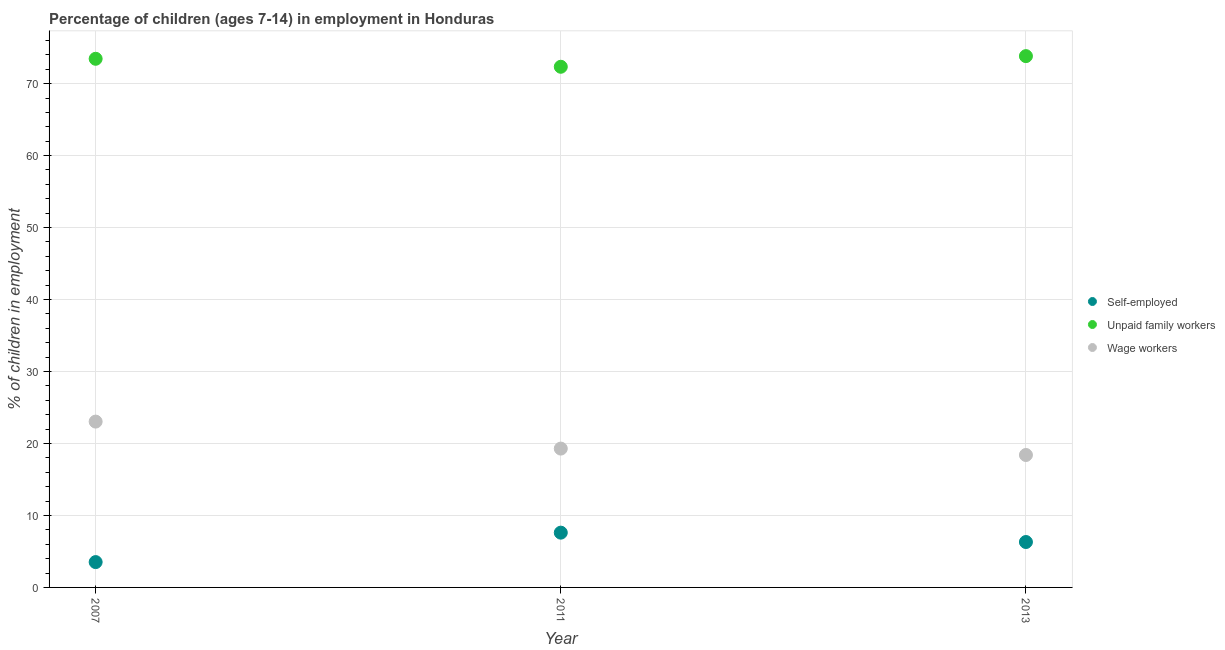How many different coloured dotlines are there?
Offer a terse response. 3. What is the percentage of self employed children in 2011?
Offer a terse response. 7.61. Across all years, what is the maximum percentage of self employed children?
Ensure brevity in your answer.  7.61. Across all years, what is the minimum percentage of children employed as unpaid family workers?
Offer a terse response. 72.34. In which year was the percentage of children employed as unpaid family workers maximum?
Offer a very short reply. 2013. What is the total percentage of self employed children in the graph?
Your answer should be very brief. 17.44. What is the difference between the percentage of children employed as wage workers in 2007 and that in 2011?
Provide a short and direct response. 3.75. What is the difference between the percentage of self employed children in 2011 and the percentage of children employed as unpaid family workers in 2013?
Your answer should be compact. -66.21. What is the average percentage of children employed as unpaid family workers per year?
Give a very brief answer. 73.2. In the year 2011, what is the difference between the percentage of children employed as unpaid family workers and percentage of self employed children?
Provide a succinct answer. 64.73. In how many years, is the percentage of children employed as wage workers greater than 16 %?
Ensure brevity in your answer.  3. What is the ratio of the percentage of children employed as wage workers in 2007 to that in 2013?
Your answer should be very brief. 1.25. Is the percentage of children employed as wage workers in 2007 less than that in 2011?
Keep it short and to the point. No. Is the difference between the percentage of children employed as unpaid family workers in 2007 and 2013 greater than the difference between the percentage of self employed children in 2007 and 2013?
Your response must be concise. Yes. What is the difference between the highest and the second highest percentage of children employed as wage workers?
Provide a succinct answer. 3.75. What is the difference between the highest and the lowest percentage of children employed as unpaid family workers?
Provide a succinct answer. 1.48. Does the percentage of children employed as unpaid family workers monotonically increase over the years?
Make the answer very short. No. Is the percentage of children employed as wage workers strictly greater than the percentage of self employed children over the years?
Your response must be concise. Yes. Is the percentage of children employed as wage workers strictly less than the percentage of children employed as unpaid family workers over the years?
Offer a terse response. Yes. How many dotlines are there?
Make the answer very short. 3. How many years are there in the graph?
Keep it short and to the point. 3. Are the values on the major ticks of Y-axis written in scientific E-notation?
Provide a succinct answer. No. How many legend labels are there?
Your answer should be compact. 3. How are the legend labels stacked?
Ensure brevity in your answer.  Vertical. What is the title of the graph?
Keep it short and to the point. Percentage of children (ages 7-14) in employment in Honduras. Does "Spain" appear as one of the legend labels in the graph?
Provide a short and direct response. No. What is the label or title of the Y-axis?
Offer a very short reply. % of children in employment. What is the % of children in employment of Self-employed in 2007?
Keep it short and to the point. 3.52. What is the % of children in employment of Unpaid family workers in 2007?
Offer a very short reply. 73.45. What is the % of children in employment of Wage workers in 2007?
Give a very brief answer. 23.04. What is the % of children in employment in Self-employed in 2011?
Give a very brief answer. 7.61. What is the % of children in employment in Unpaid family workers in 2011?
Your answer should be very brief. 72.34. What is the % of children in employment of Wage workers in 2011?
Offer a very short reply. 19.29. What is the % of children in employment in Self-employed in 2013?
Ensure brevity in your answer.  6.31. What is the % of children in employment in Unpaid family workers in 2013?
Your response must be concise. 73.82. What is the % of children in employment of Wage workers in 2013?
Your response must be concise. 18.4. Across all years, what is the maximum % of children in employment in Self-employed?
Provide a short and direct response. 7.61. Across all years, what is the maximum % of children in employment of Unpaid family workers?
Your answer should be very brief. 73.82. Across all years, what is the maximum % of children in employment in Wage workers?
Provide a short and direct response. 23.04. Across all years, what is the minimum % of children in employment in Self-employed?
Offer a terse response. 3.52. Across all years, what is the minimum % of children in employment of Unpaid family workers?
Provide a succinct answer. 72.34. Across all years, what is the minimum % of children in employment of Wage workers?
Offer a very short reply. 18.4. What is the total % of children in employment of Self-employed in the graph?
Your response must be concise. 17.44. What is the total % of children in employment of Unpaid family workers in the graph?
Make the answer very short. 219.61. What is the total % of children in employment in Wage workers in the graph?
Your response must be concise. 60.73. What is the difference between the % of children in employment in Self-employed in 2007 and that in 2011?
Your response must be concise. -4.09. What is the difference between the % of children in employment in Unpaid family workers in 2007 and that in 2011?
Give a very brief answer. 1.11. What is the difference between the % of children in employment of Wage workers in 2007 and that in 2011?
Keep it short and to the point. 3.75. What is the difference between the % of children in employment of Self-employed in 2007 and that in 2013?
Provide a succinct answer. -2.79. What is the difference between the % of children in employment in Unpaid family workers in 2007 and that in 2013?
Your answer should be compact. -0.37. What is the difference between the % of children in employment of Wage workers in 2007 and that in 2013?
Offer a very short reply. 4.64. What is the difference between the % of children in employment in Self-employed in 2011 and that in 2013?
Keep it short and to the point. 1.3. What is the difference between the % of children in employment of Unpaid family workers in 2011 and that in 2013?
Provide a succinct answer. -1.48. What is the difference between the % of children in employment in Wage workers in 2011 and that in 2013?
Your response must be concise. 0.89. What is the difference between the % of children in employment of Self-employed in 2007 and the % of children in employment of Unpaid family workers in 2011?
Make the answer very short. -68.82. What is the difference between the % of children in employment of Self-employed in 2007 and the % of children in employment of Wage workers in 2011?
Keep it short and to the point. -15.77. What is the difference between the % of children in employment of Unpaid family workers in 2007 and the % of children in employment of Wage workers in 2011?
Give a very brief answer. 54.16. What is the difference between the % of children in employment in Self-employed in 2007 and the % of children in employment in Unpaid family workers in 2013?
Offer a very short reply. -70.3. What is the difference between the % of children in employment of Self-employed in 2007 and the % of children in employment of Wage workers in 2013?
Provide a short and direct response. -14.88. What is the difference between the % of children in employment of Unpaid family workers in 2007 and the % of children in employment of Wage workers in 2013?
Ensure brevity in your answer.  55.05. What is the difference between the % of children in employment in Self-employed in 2011 and the % of children in employment in Unpaid family workers in 2013?
Provide a succinct answer. -66.21. What is the difference between the % of children in employment of Self-employed in 2011 and the % of children in employment of Wage workers in 2013?
Provide a succinct answer. -10.79. What is the difference between the % of children in employment in Unpaid family workers in 2011 and the % of children in employment in Wage workers in 2013?
Provide a short and direct response. 53.94. What is the average % of children in employment of Self-employed per year?
Ensure brevity in your answer.  5.81. What is the average % of children in employment of Unpaid family workers per year?
Your answer should be compact. 73.2. What is the average % of children in employment of Wage workers per year?
Make the answer very short. 20.24. In the year 2007, what is the difference between the % of children in employment of Self-employed and % of children in employment of Unpaid family workers?
Offer a very short reply. -69.93. In the year 2007, what is the difference between the % of children in employment in Self-employed and % of children in employment in Wage workers?
Provide a succinct answer. -19.52. In the year 2007, what is the difference between the % of children in employment in Unpaid family workers and % of children in employment in Wage workers?
Provide a succinct answer. 50.41. In the year 2011, what is the difference between the % of children in employment in Self-employed and % of children in employment in Unpaid family workers?
Keep it short and to the point. -64.73. In the year 2011, what is the difference between the % of children in employment in Self-employed and % of children in employment in Wage workers?
Your answer should be very brief. -11.68. In the year 2011, what is the difference between the % of children in employment of Unpaid family workers and % of children in employment of Wage workers?
Ensure brevity in your answer.  53.05. In the year 2013, what is the difference between the % of children in employment in Self-employed and % of children in employment in Unpaid family workers?
Provide a short and direct response. -67.51. In the year 2013, what is the difference between the % of children in employment of Self-employed and % of children in employment of Wage workers?
Your answer should be very brief. -12.09. In the year 2013, what is the difference between the % of children in employment of Unpaid family workers and % of children in employment of Wage workers?
Provide a short and direct response. 55.42. What is the ratio of the % of children in employment of Self-employed in 2007 to that in 2011?
Give a very brief answer. 0.46. What is the ratio of the % of children in employment in Unpaid family workers in 2007 to that in 2011?
Offer a very short reply. 1.02. What is the ratio of the % of children in employment of Wage workers in 2007 to that in 2011?
Provide a short and direct response. 1.19. What is the ratio of the % of children in employment of Self-employed in 2007 to that in 2013?
Ensure brevity in your answer.  0.56. What is the ratio of the % of children in employment in Unpaid family workers in 2007 to that in 2013?
Ensure brevity in your answer.  0.99. What is the ratio of the % of children in employment of Wage workers in 2007 to that in 2013?
Your answer should be very brief. 1.25. What is the ratio of the % of children in employment of Self-employed in 2011 to that in 2013?
Offer a terse response. 1.21. What is the ratio of the % of children in employment of Wage workers in 2011 to that in 2013?
Offer a terse response. 1.05. What is the difference between the highest and the second highest % of children in employment in Self-employed?
Provide a short and direct response. 1.3. What is the difference between the highest and the second highest % of children in employment in Unpaid family workers?
Your response must be concise. 0.37. What is the difference between the highest and the second highest % of children in employment in Wage workers?
Your response must be concise. 3.75. What is the difference between the highest and the lowest % of children in employment of Self-employed?
Your answer should be very brief. 4.09. What is the difference between the highest and the lowest % of children in employment in Unpaid family workers?
Your answer should be very brief. 1.48. What is the difference between the highest and the lowest % of children in employment in Wage workers?
Offer a terse response. 4.64. 